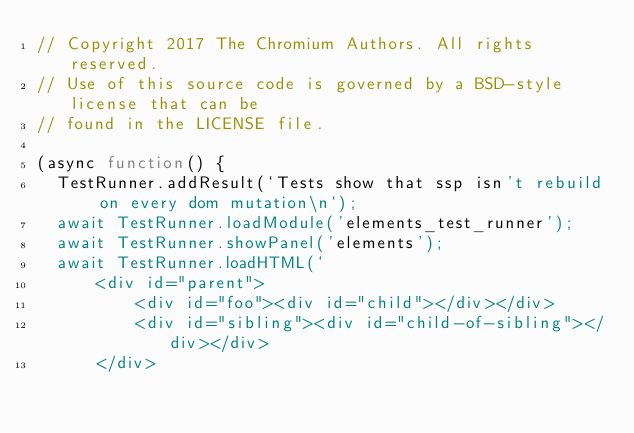<code> <loc_0><loc_0><loc_500><loc_500><_JavaScript_>// Copyright 2017 The Chromium Authors. All rights reserved.
// Use of this source code is governed by a BSD-style license that can be
// found in the LICENSE file.

(async function() {
  TestRunner.addResult(`Tests show that ssp isn't rebuild on every dom mutation\n`);
  await TestRunner.loadModule('elements_test_runner');
  await TestRunner.showPanel('elements');
  await TestRunner.loadHTML(`
      <div id="parent">
          <div id="foo"><div id="child"></div></div>
          <div id="sibling"><div id="child-of-sibling"></div></div>
      </div></code> 